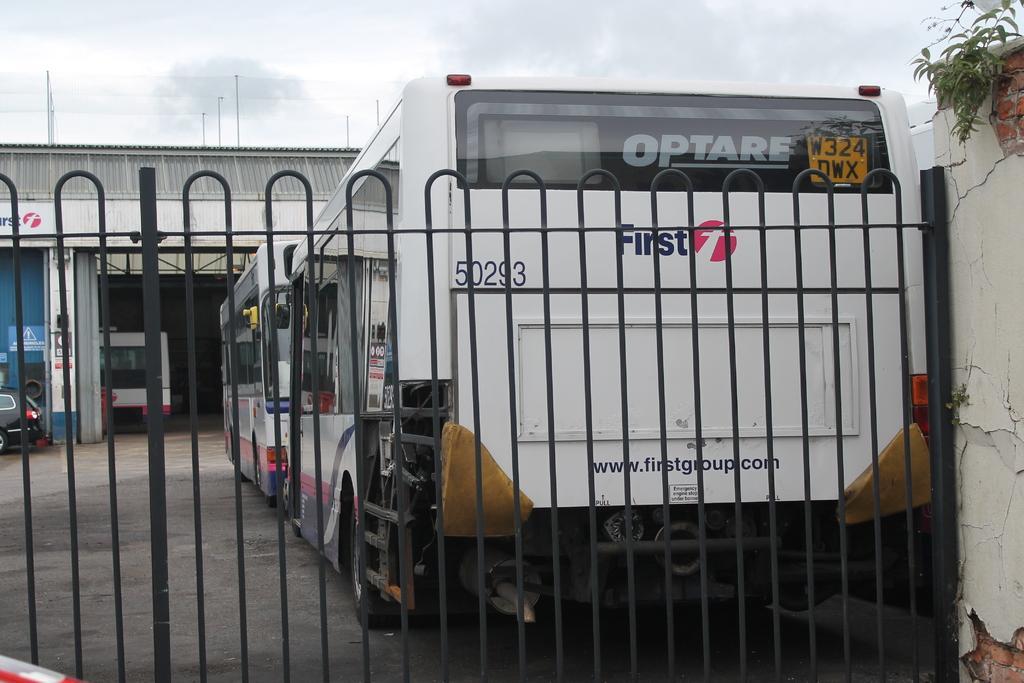Describe this image in one or two sentences. In this image we can see a railing. In the back there are buses. Also there is a building. On the right side there is a wall. Also there is a plant. In the background there is sky with clouds. On the bus we can see numbers and words. 